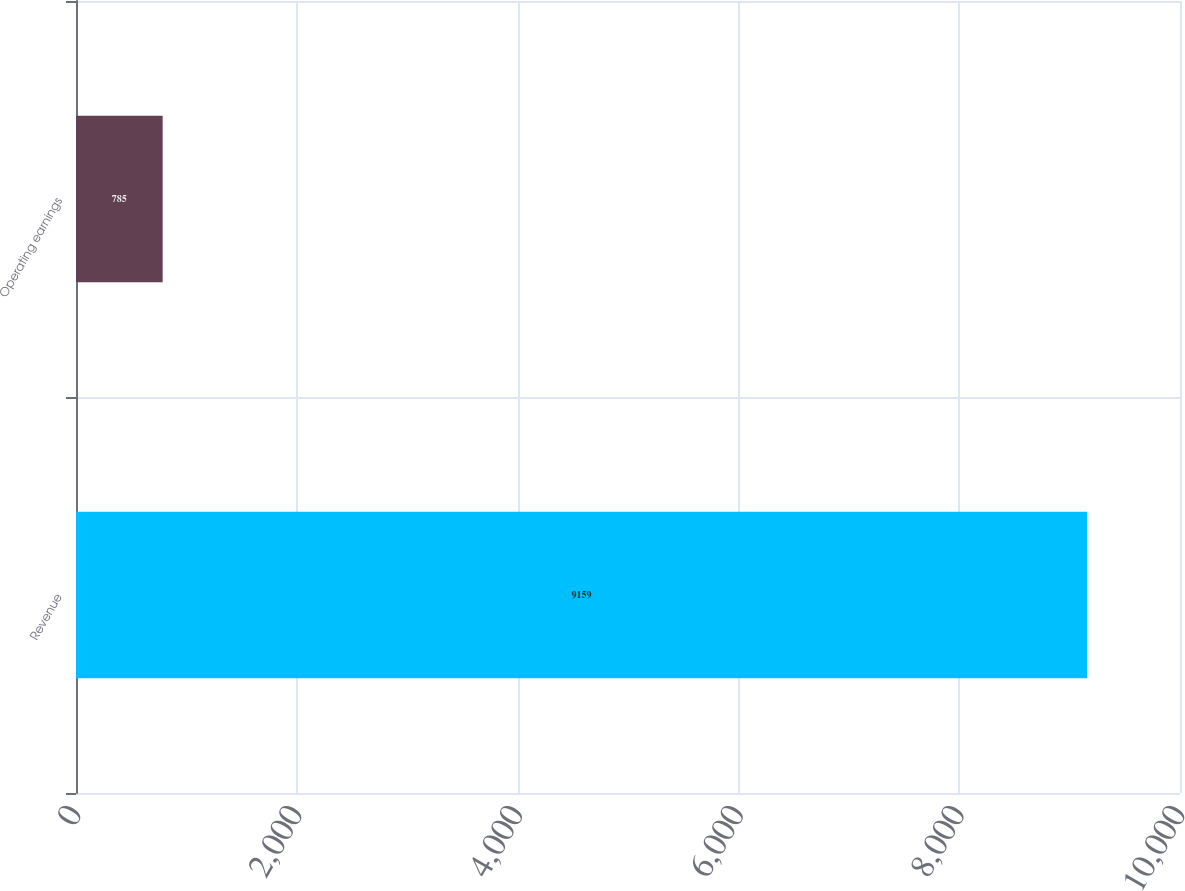Convert chart. <chart><loc_0><loc_0><loc_500><loc_500><bar_chart><fcel>Revenue<fcel>Operating earnings<nl><fcel>9159<fcel>785<nl></chart> 